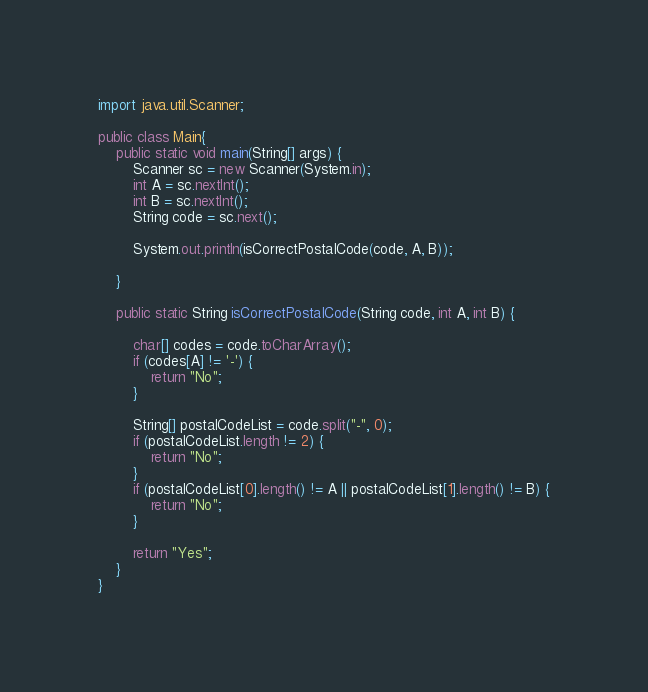Convert code to text. <code><loc_0><loc_0><loc_500><loc_500><_Java_>import java.util.Scanner;

public class Main{
	public static void main(String[] args) {
		Scanner sc = new Scanner(System.in);
		int A = sc.nextInt();
		int B = sc.nextInt();
		String code = sc.next();

		System.out.println(isCorrectPostalCode(code, A, B));

	}

	public static String isCorrectPostalCode(String code, int A, int B) {

		char[] codes = code.toCharArray();
		if (codes[A] != '-') {
			return "No";
		}

		String[] postalCodeList = code.split("-", 0);
		if (postalCodeList.length != 2) {
			return "No";
		}
		if (postalCodeList[0].length() != A || postalCodeList[1].length() != B) {
			return "No";
		}

		return "Yes";
	}
}
</code> 